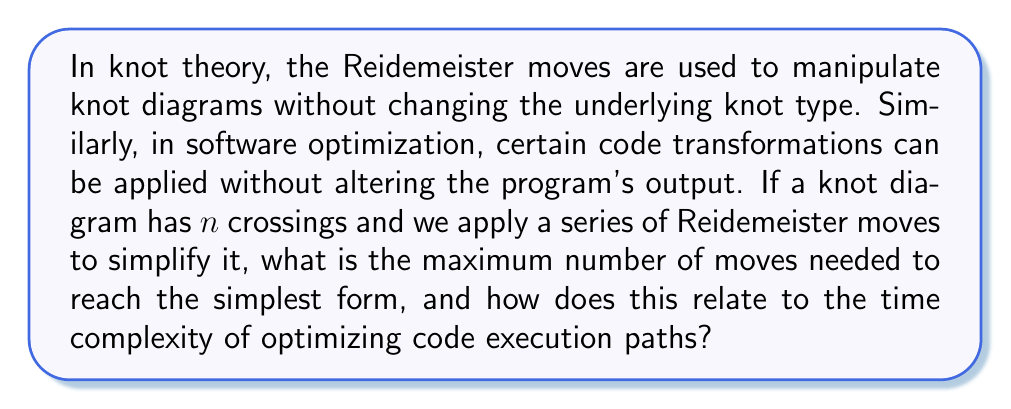Can you answer this question? To answer this question, we need to consider the following steps:

1. Understanding Reidemeister moves:
   There are three types of Reidemeister moves (I, II, and III) that can be applied to a knot diagram without changing the knot type.

2. Maximum number of moves:
   The upper bound for the number of Reidemeister moves needed to simplify a knot diagram with $n$ crossings is given by:

   $$2^{c n^2}$$

   Where $c$ is a constant, typically around 10^11.

3. Time complexity analysis:
   The time complexity of this process can be expressed as:

   $$O(2^{c n^2})$$

   This is an exponential time complexity.

4. Relation to code optimization:
   In code optimization, we often encounter similar challenges where the number of possible execution paths grows exponentially with the number of decision points or branches in the code.

5. Code optimization analogy:
   If we consider each crossing in the knot diagram as analogous to a decision point in code, then the process of simplifying the knot diagram is similar to optimizing code execution paths.

6. Implications for debugging:
   For a software architect focusing on advanced debugging strategies, this analogy suggests that optimizing complex code paths may require an exponential number of transformations in the worst case, similar to untangling a complex knot.

7. Practical considerations:
   In practice, both knot simplification and code optimization often use heuristics and approximations to achieve reasonable results in polynomial time, as the exponential approach is typically infeasible for large problems.
Answer: $O(2^{c n^2})$, exponential complexity 